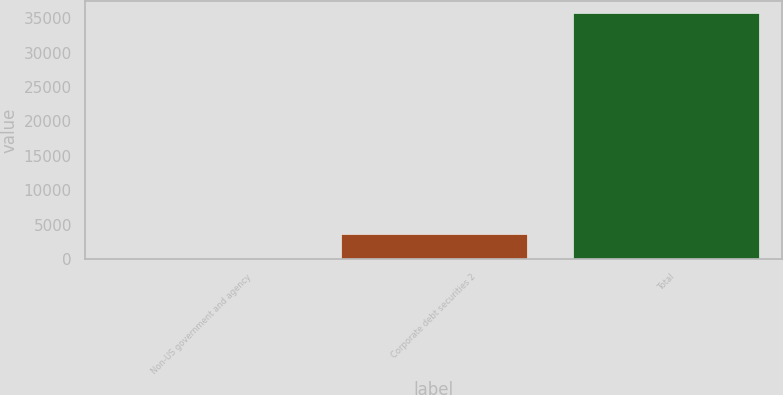Convert chart to OTSL. <chart><loc_0><loc_0><loc_500><loc_500><bar_chart><fcel>Non-US government and agency<fcel>Corporate debt securities 2<fcel>Total<nl><fcel>26<fcel>3598.3<fcel>35749<nl></chart> 